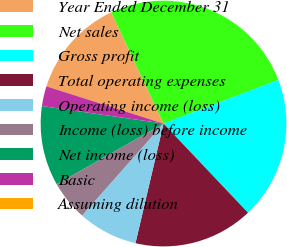Convert chart. <chart><loc_0><loc_0><loc_500><loc_500><pie_chart><fcel>Year Ended December 31<fcel>Net sales<fcel>Gross profit<fcel>Total operating expenses<fcel>Operating income (loss)<fcel>Income (loss) before income<fcel>Net income (loss)<fcel>Basic<fcel>Assuming dilution<nl><fcel>13.11%<fcel>26.22%<fcel>18.71%<fcel>15.73%<fcel>7.87%<fcel>5.25%<fcel>10.49%<fcel>2.62%<fcel>0.0%<nl></chart> 